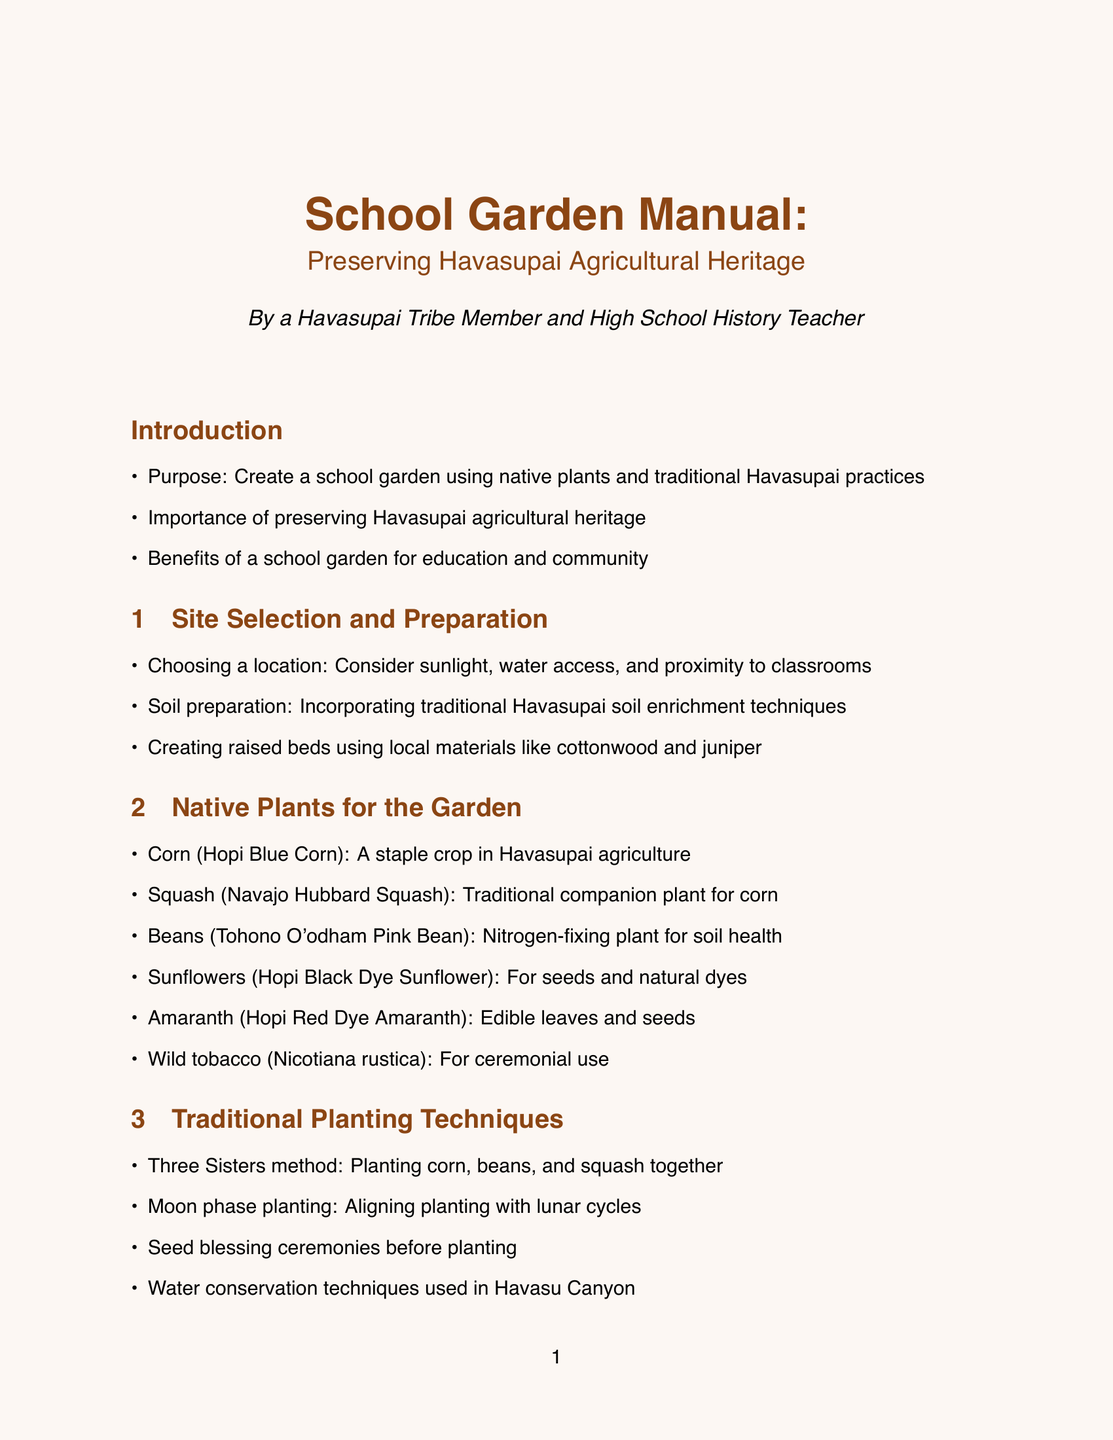What is the purpose of the manual? The purpose is to create a school garden using native plants and traditional Havasupai practices.
Answer: To create a school garden using native plants and traditional Havasupai practices What is the traditional Havasupai method for planting corn, beans, and squash together? The method is a cooperative planting technique that benefits all three plants.
Answer: Three Sisters method What crop is referred to as a staple in Havasupai agriculture? This crop is essential for Havasupai farming and nutrition.
Answer: Corn (Hopi Blue Corn) What irrigation method is traditionally used by the Havasupai? This method involves watering fields by flooding with water.
Answer: Flood Irrigation How many native plants for the garden are listed in the document? The document outlines various native plants that can be incorporated into the garden.
Answer: Six What community activity is suggested to promote agricultural knowledge? This activity involves engaging elders in sharing their expertise with students.
Answer: Organizing community harvest festivals What phase is considered important for planting according to traditional techniques? This natural phenomenon aligns with cycles in agriculture for optimal planting.
Answer: Moon phase planting What does the document recommend for maintaining soil health? This practice helps replenish nutrients in the garden.
Answer: Crop rotation practices 